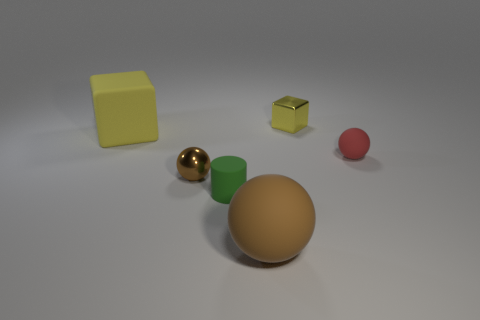There is a brown matte sphere; is its size the same as the matte object that is behind the tiny red sphere?
Give a very brief answer. Yes. Are there any cylinders in front of the yellow object that is right of the large rubber sphere?
Your answer should be very brief. Yes. What is the small thing that is behind the tiny brown metal sphere and on the left side of the tiny rubber ball made of?
Give a very brief answer. Metal. The metal thing that is behind the brown thing that is left of the big object that is in front of the matte block is what color?
Your answer should be compact. Yellow. The metallic block that is the same size as the matte cylinder is what color?
Provide a succinct answer. Yellow. Is the color of the large rubber sphere the same as the metallic sphere that is left of the tiny metal cube?
Keep it short and to the point. Yes. There is a large object that is behind the tiny object that is right of the yellow metallic block; what is it made of?
Provide a succinct answer. Rubber. How many objects are both to the right of the tiny cylinder and behind the green cylinder?
Provide a short and direct response. 2. What number of other objects are there of the same size as the yellow rubber cube?
Your response must be concise. 1. There is a big object to the right of the green object; is it the same shape as the shiny thing in front of the big yellow rubber cube?
Your response must be concise. Yes. 